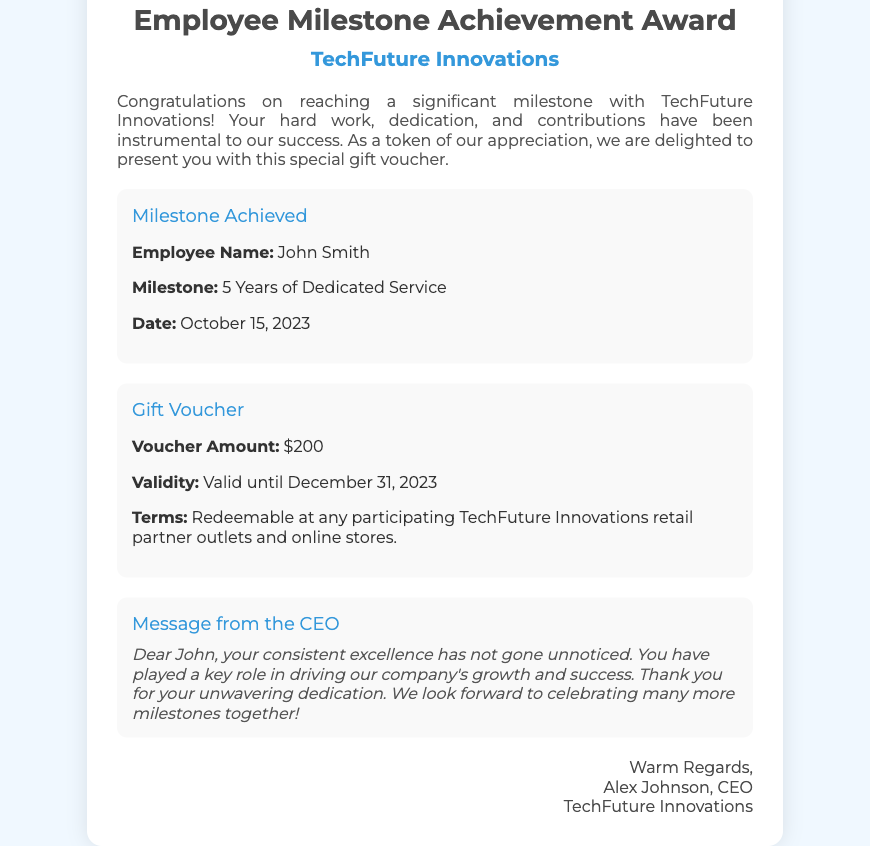what is the name of the employee? The document specifically states the employee's name in the details section.
Answer: John Smith what is the milestone achievement? The details section clearly mentions the specific milestone that the employee has achieved.
Answer: 5 Years of Dedicated Service what is the voucher amount? The voucher amount is stated in the gift voucher section of the document.
Answer: $200 what is the validity period of the voucher? The validity of the voucher is mentioned in the details section which specifies until when it can be redeemed.
Answer: Valid until December 31, 2023 who issued the voucher? The closing section at the end of the document states who is signing off on the voucher.
Answer: Alex Johnson why was the voucher issued to John Smith? The introduction section and message from the CEO both explain the purpose of the gift voucher.
Answer: For reaching a significant milestone what can the voucher be redeemed for? The terms in the gift voucher section specify where the voucher can be used.
Answer: At any participating TechFuture Innovations retail partner outlets and online stores when was the milestone achieved? The date for the milestone achievement is listed in the details section.
Answer: October 15, 2023 